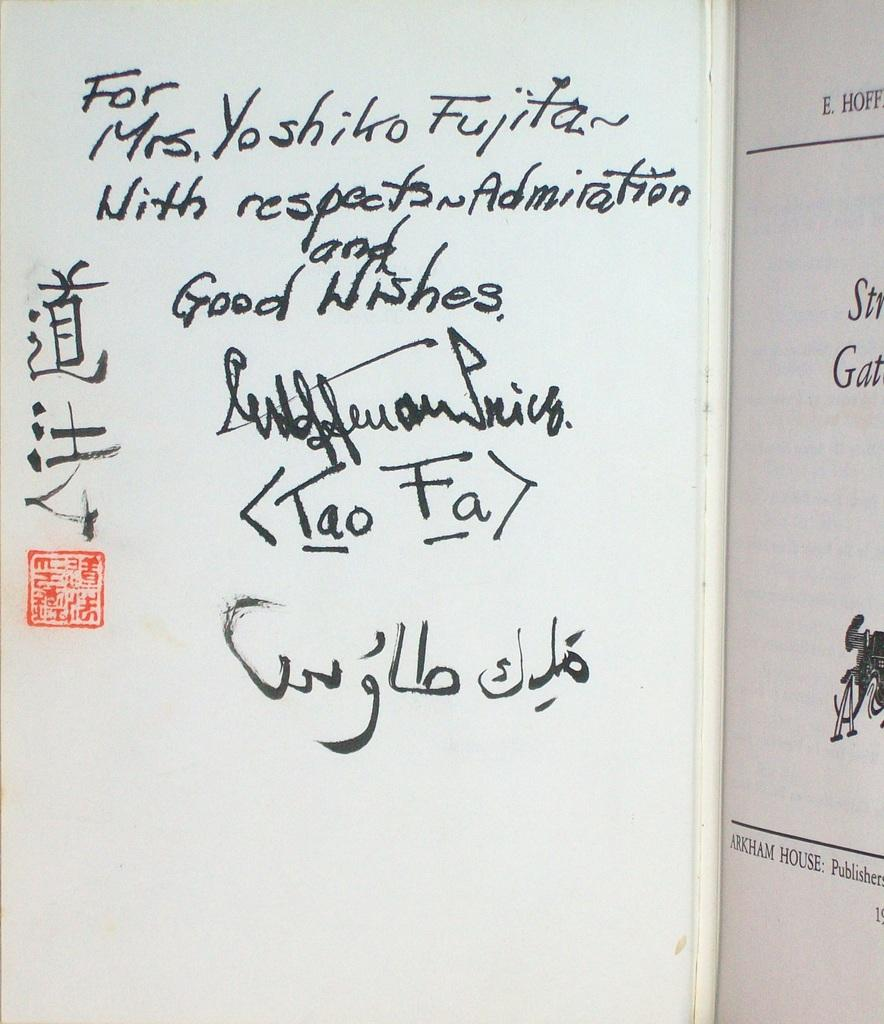<image>
Present a compact description of the photo's key features. Someone has written a note to Mrs. Yoshiko Fujita in black ink. 